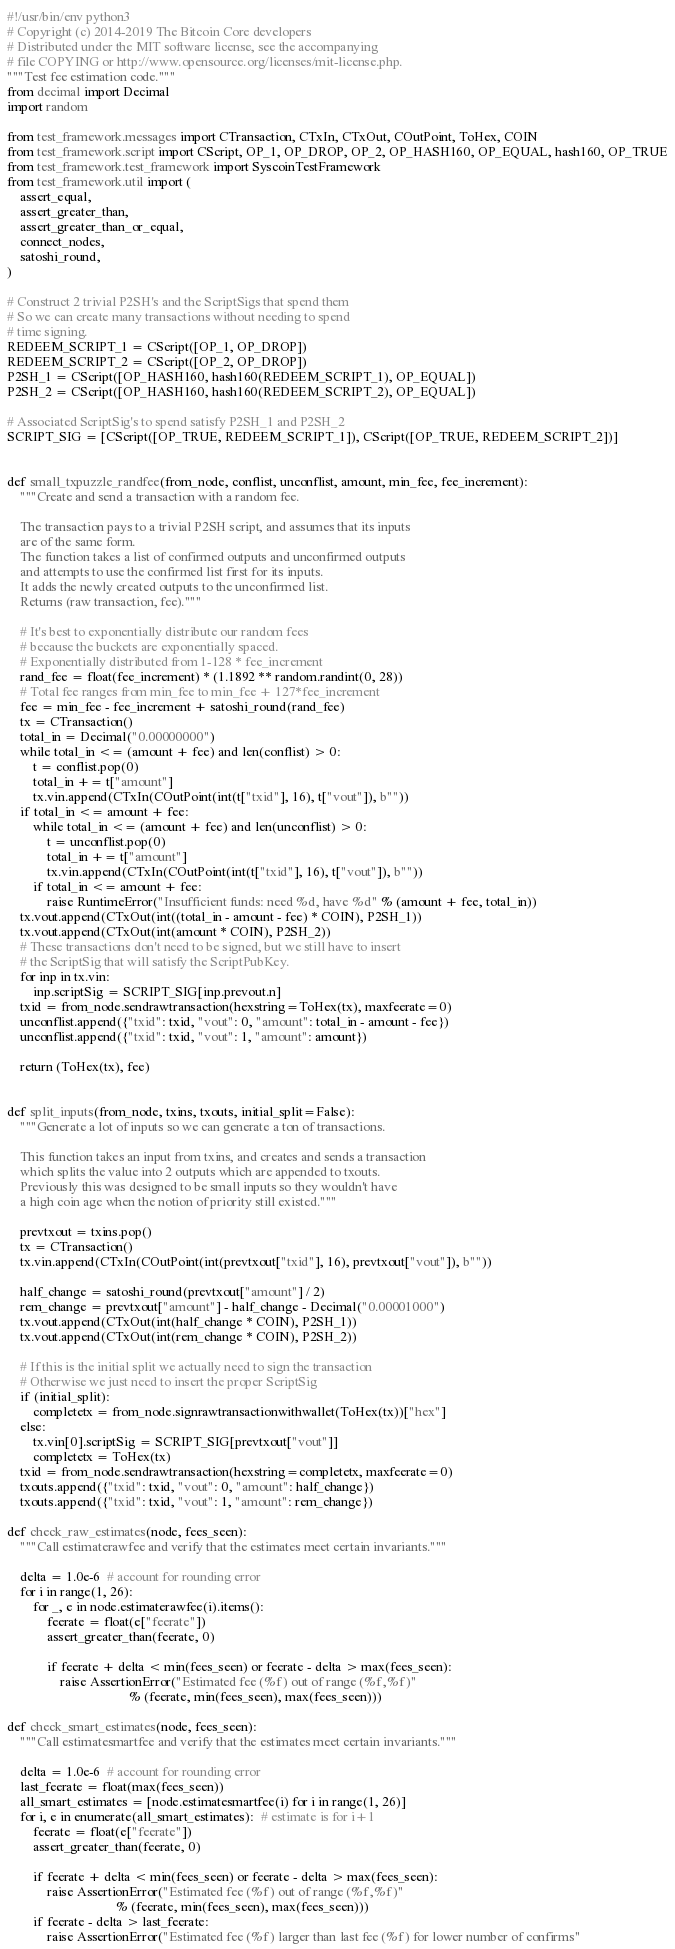Convert code to text. <code><loc_0><loc_0><loc_500><loc_500><_Python_>#!/usr/bin/env python3
# Copyright (c) 2014-2019 The Bitcoin Core developers
# Distributed under the MIT software license, see the accompanying
# file COPYING or http://www.opensource.org/licenses/mit-license.php.
"""Test fee estimation code."""
from decimal import Decimal
import random

from test_framework.messages import CTransaction, CTxIn, CTxOut, COutPoint, ToHex, COIN
from test_framework.script import CScript, OP_1, OP_DROP, OP_2, OP_HASH160, OP_EQUAL, hash160, OP_TRUE
from test_framework.test_framework import SyscoinTestFramework
from test_framework.util import (
    assert_equal,
    assert_greater_than,
    assert_greater_than_or_equal,
    connect_nodes,
    satoshi_round,
)

# Construct 2 trivial P2SH's and the ScriptSigs that spend them
# So we can create many transactions without needing to spend
# time signing.
REDEEM_SCRIPT_1 = CScript([OP_1, OP_DROP])
REDEEM_SCRIPT_2 = CScript([OP_2, OP_DROP])
P2SH_1 = CScript([OP_HASH160, hash160(REDEEM_SCRIPT_1), OP_EQUAL])
P2SH_2 = CScript([OP_HASH160, hash160(REDEEM_SCRIPT_2), OP_EQUAL])

# Associated ScriptSig's to spend satisfy P2SH_1 and P2SH_2
SCRIPT_SIG = [CScript([OP_TRUE, REDEEM_SCRIPT_1]), CScript([OP_TRUE, REDEEM_SCRIPT_2])]


def small_txpuzzle_randfee(from_node, conflist, unconflist, amount, min_fee, fee_increment):
    """Create and send a transaction with a random fee.

    The transaction pays to a trivial P2SH script, and assumes that its inputs
    are of the same form.
    The function takes a list of confirmed outputs and unconfirmed outputs
    and attempts to use the confirmed list first for its inputs.
    It adds the newly created outputs to the unconfirmed list.
    Returns (raw transaction, fee)."""

    # It's best to exponentially distribute our random fees
    # because the buckets are exponentially spaced.
    # Exponentially distributed from 1-128 * fee_increment
    rand_fee = float(fee_increment) * (1.1892 ** random.randint(0, 28))
    # Total fee ranges from min_fee to min_fee + 127*fee_increment
    fee = min_fee - fee_increment + satoshi_round(rand_fee)
    tx = CTransaction()
    total_in = Decimal("0.00000000")
    while total_in <= (amount + fee) and len(conflist) > 0:
        t = conflist.pop(0)
        total_in += t["amount"]
        tx.vin.append(CTxIn(COutPoint(int(t["txid"], 16), t["vout"]), b""))
    if total_in <= amount + fee:
        while total_in <= (amount + fee) and len(unconflist) > 0:
            t = unconflist.pop(0)
            total_in += t["amount"]
            tx.vin.append(CTxIn(COutPoint(int(t["txid"], 16), t["vout"]), b""))
        if total_in <= amount + fee:
            raise RuntimeError("Insufficient funds: need %d, have %d" % (amount + fee, total_in))
    tx.vout.append(CTxOut(int((total_in - amount - fee) * COIN), P2SH_1))
    tx.vout.append(CTxOut(int(amount * COIN), P2SH_2))
    # These transactions don't need to be signed, but we still have to insert
    # the ScriptSig that will satisfy the ScriptPubKey.
    for inp in tx.vin:
        inp.scriptSig = SCRIPT_SIG[inp.prevout.n]
    txid = from_node.sendrawtransaction(hexstring=ToHex(tx), maxfeerate=0)
    unconflist.append({"txid": txid, "vout": 0, "amount": total_in - amount - fee})
    unconflist.append({"txid": txid, "vout": 1, "amount": amount})

    return (ToHex(tx), fee)


def split_inputs(from_node, txins, txouts, initial_split=False):
    """Generate a lot of inputs so we can generate a ton of transactions.

    This function takes an input from txins, and creates and sends a transaction
    which splits the value into 2 outputs which are appended to txouts.
    Previously this was designed to be small inputs so they wouldn't have
    a high coin age when the notion of priority still existed."""

    prevtxout = txins.pop()
    tx = CTransaction()
    tx.vin.append(CTxIn(COutPoint(int(prevtxout["txid"], 16), prevtxout["vout"]), b""))

    half_change = satoshi_round(prevtxout["amount"] / 2)
    rem_change = prevtxout["amount"] - half_change - Decimal("0.00001000")
    tx.vout.append(CTxOut(int(half_change * COIN), P2SH_1))
    tx.vout.append(CTxOut(int(rem_change * COIN), P2SH_2))

    # If this is the initial split we actually need to sign the transaction
    # Otherwise we just need to insert the proper ScriptSig
    if (initial_split):
        completetx = from_node.signrawtransactionwithwallet(ToHex(tx))["hex"]
    else:
        tx.vin[0].scriptSig = SCRIPT_SIG[prevtxout["vout"]]
        completetx = ToHex(tx)
    txid = from_node.sendrawtransaction(hexstring=completetx, maxfeerate=0)
    txouts.append({"txid": txid, "vout": 0, "amount": half_change})
    txouts.append({"txid": txid, "vout": 1, "amount": rem_change})

def check_raw_estimates(node, fees_seen):
    """Call estimaterawfee and verify that the estimates meet certain invariants."""

    delta = 1.0e-6  # account for rounding error
    for i in range(1, 26):
        for _, e in node.estimaterawfee(i).items():
            feerate = float(e["feerate"])
            assert_greater_than(feerate, 0)

            if feerate + delta < min(fees_seen) or feerate - delta > max(fees_seen):
                raise AssertionError("Estimated fee (%f) out of range (%f,%f)"
                                     % (feerate, min(fees_seen), max(fees_seen)))

def check_smart_estimates(node, fees_seen):
    """Call estimatesmartfee and verify that the estimates meet certain invariants."""

    delta = 1.0e-6  # account for rounding error
    last_feerate = float(max(fees_seen))
    all_smart_estimates = [node.estimatesmartfee(i) for i in range(1, 26)]
    for i, e in enumerate(all_smart_estimates):  # estimate is for i+1
        feerate = float(e["feerate"])
        assert_greater_than(feerate, 0)

        if feerate + delta < min(fees_seen) or feerate - delta > max(fees_seen):
            raise AssertionError("Estimated fee (%f) out of range (%f,%f)"
                                 % (feerate, min(fees_seen), max(fees_seen)))
        if feerate - delta > last_feerate:
            raise AssertionError("Estimated fee (%f) larger than last fee (%f) for lower number of confirms"</code> 